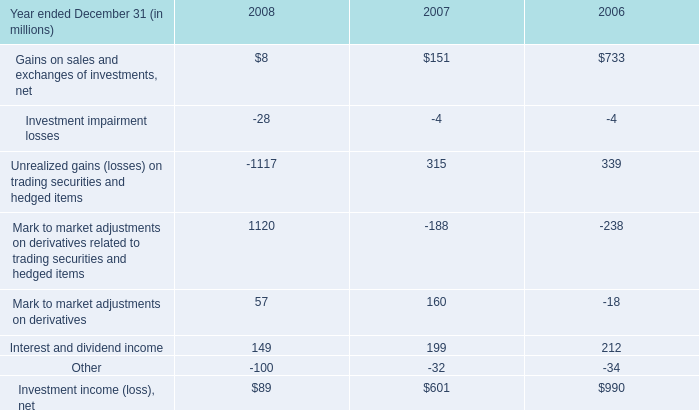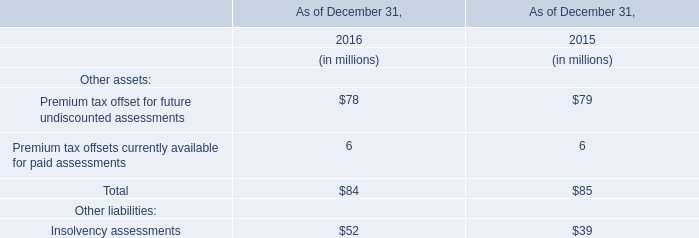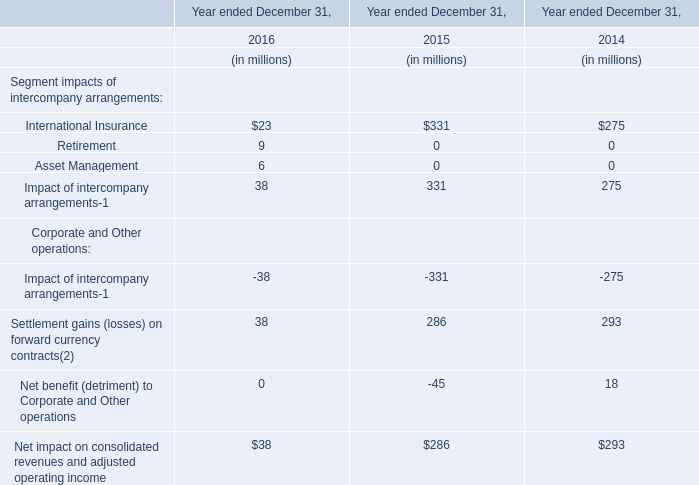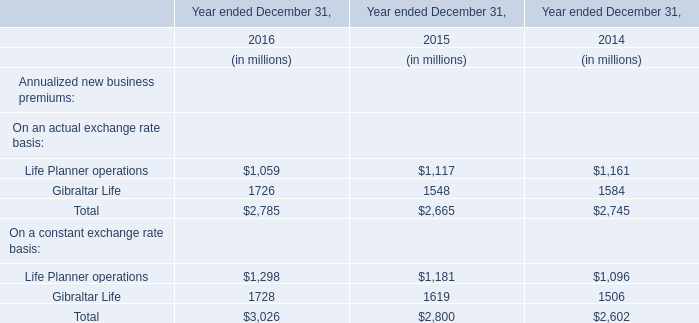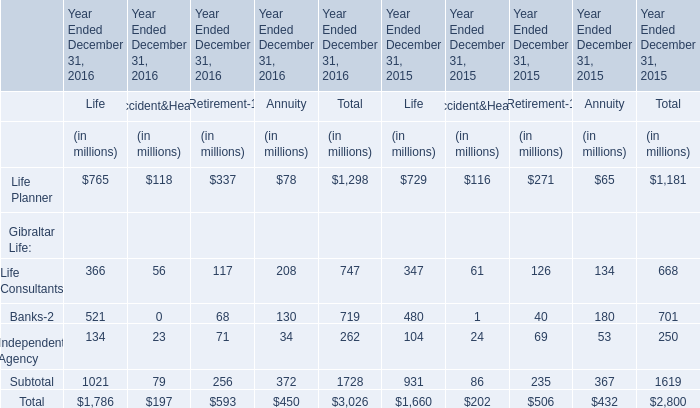What is the percentage of Life Planner in relation to the total in 2016 for Life? 
Computations: (765 / (((765 + 366) + 521) + 134))
Answer: 0.42833. 